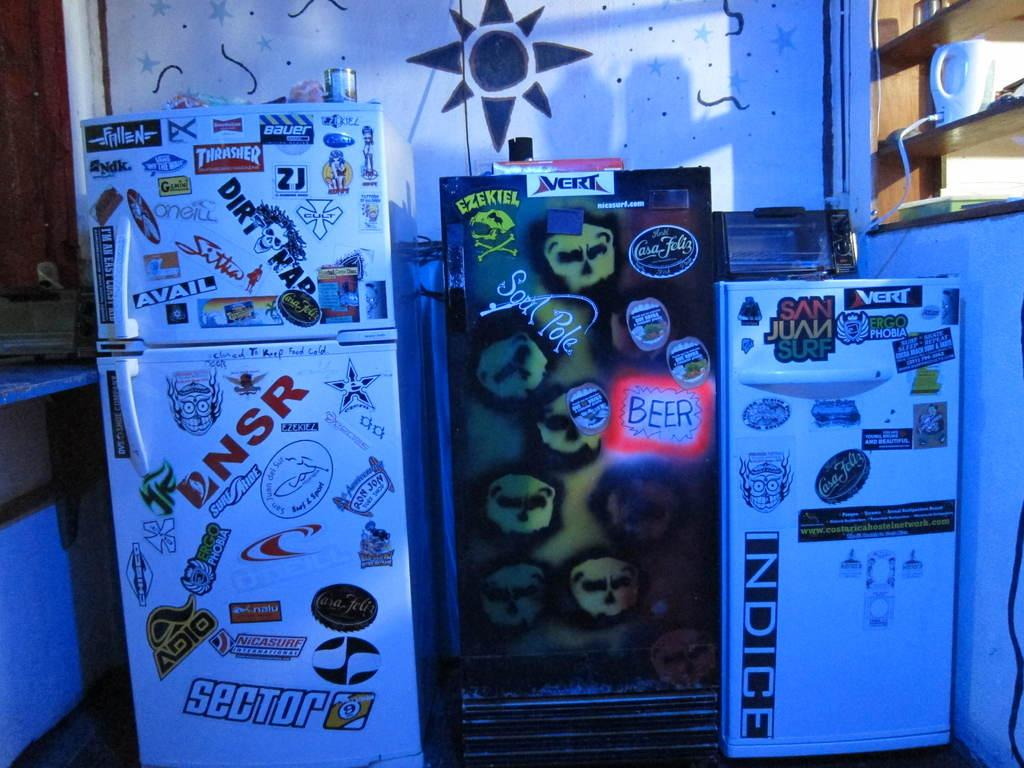<image>
Provide a brief description of the given image. a fridge that has sector at the bottom 